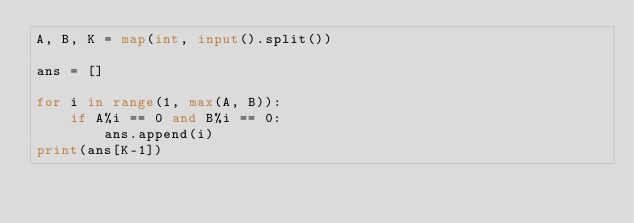Convert code to text. <code><loc_0><loc_0><loc_500><loc_500><_Python_>A, B, K = map(int, input().split())

ans = []

for i in range(1, max(A, B)):
    if A%i == 0 and B%i == 0:
        ans.append(i)
print(ans[K-1])</code> 